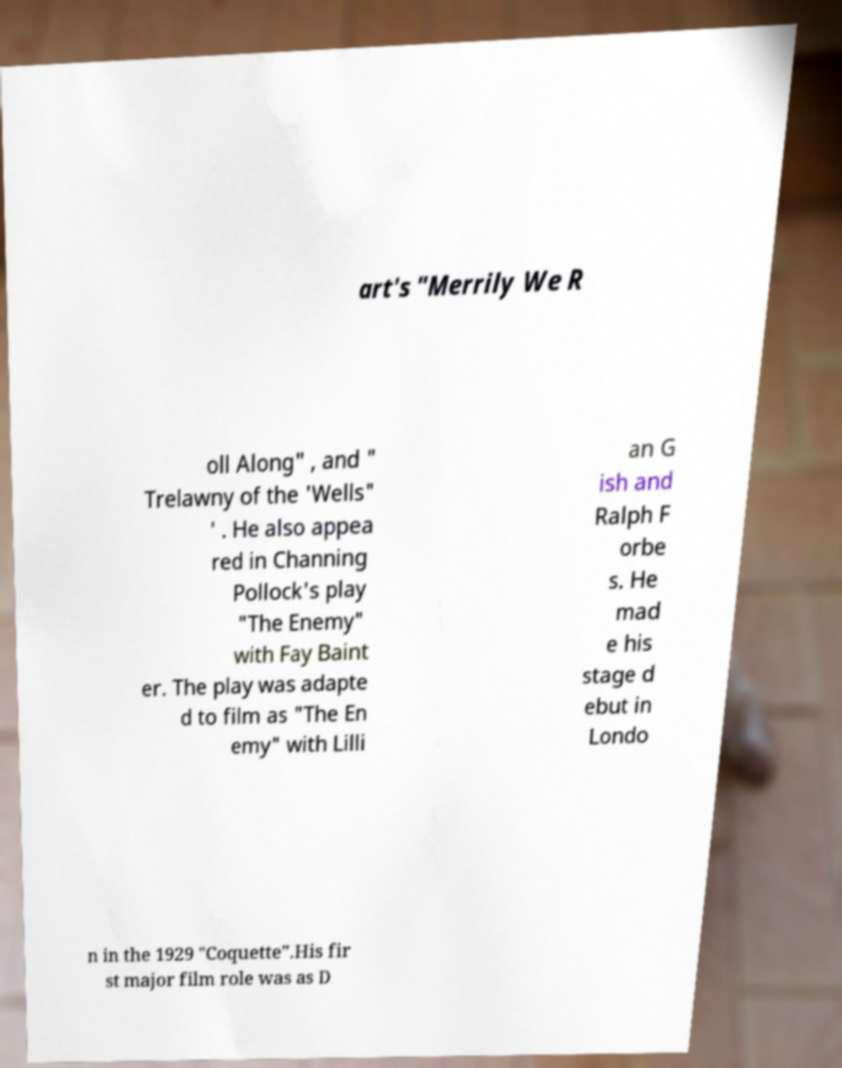For documentation purposes, I need the text within this image transcribed. Could you provide that? art's "Merrily We R oll Along" , and " Trelawny of the 'Wells" ' . He also appea red in Channing Pollock's play "The Enemy" with Fay Baint er. The play was adapte d to film as "The En emy" with Lilli an G ish and Ralph F orbe s. He mad e his stage d ebut in Londo n in the 1929 "Coquette".His fir st major film role was as D 